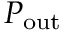Convert formula to latex. <formula><loc_0><loc_0><loc_500><loc_500>P _ { o u t }</formula> 